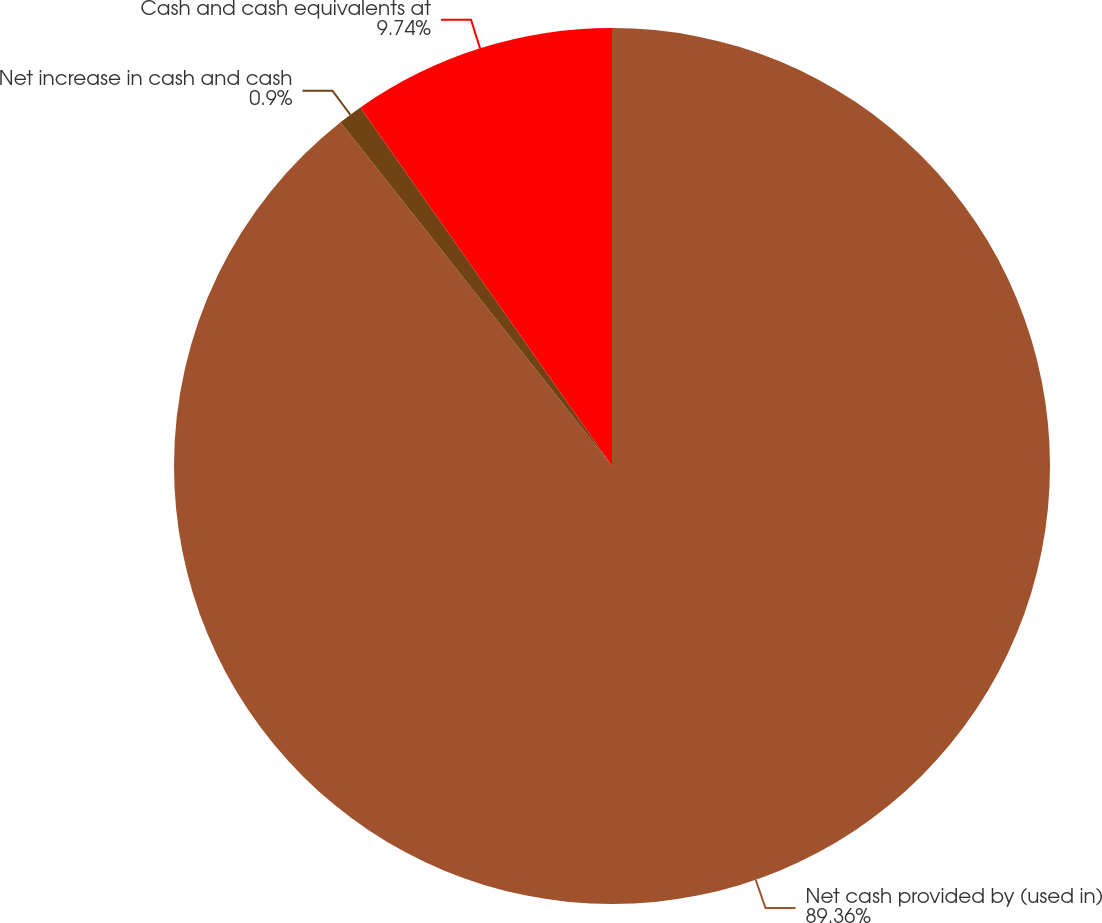Convert chart to OTSL. <chart><loc_0><loc_0><loc_500><loc_500><pie_chart><fcel>Net cash provided by (used in)<fcel>Net increase in cash and cash<fcel>Cash and cash equivalents at<nl><fcel>89.36%<fcel>0.9%<fcel>9.74%<nl></chart> 